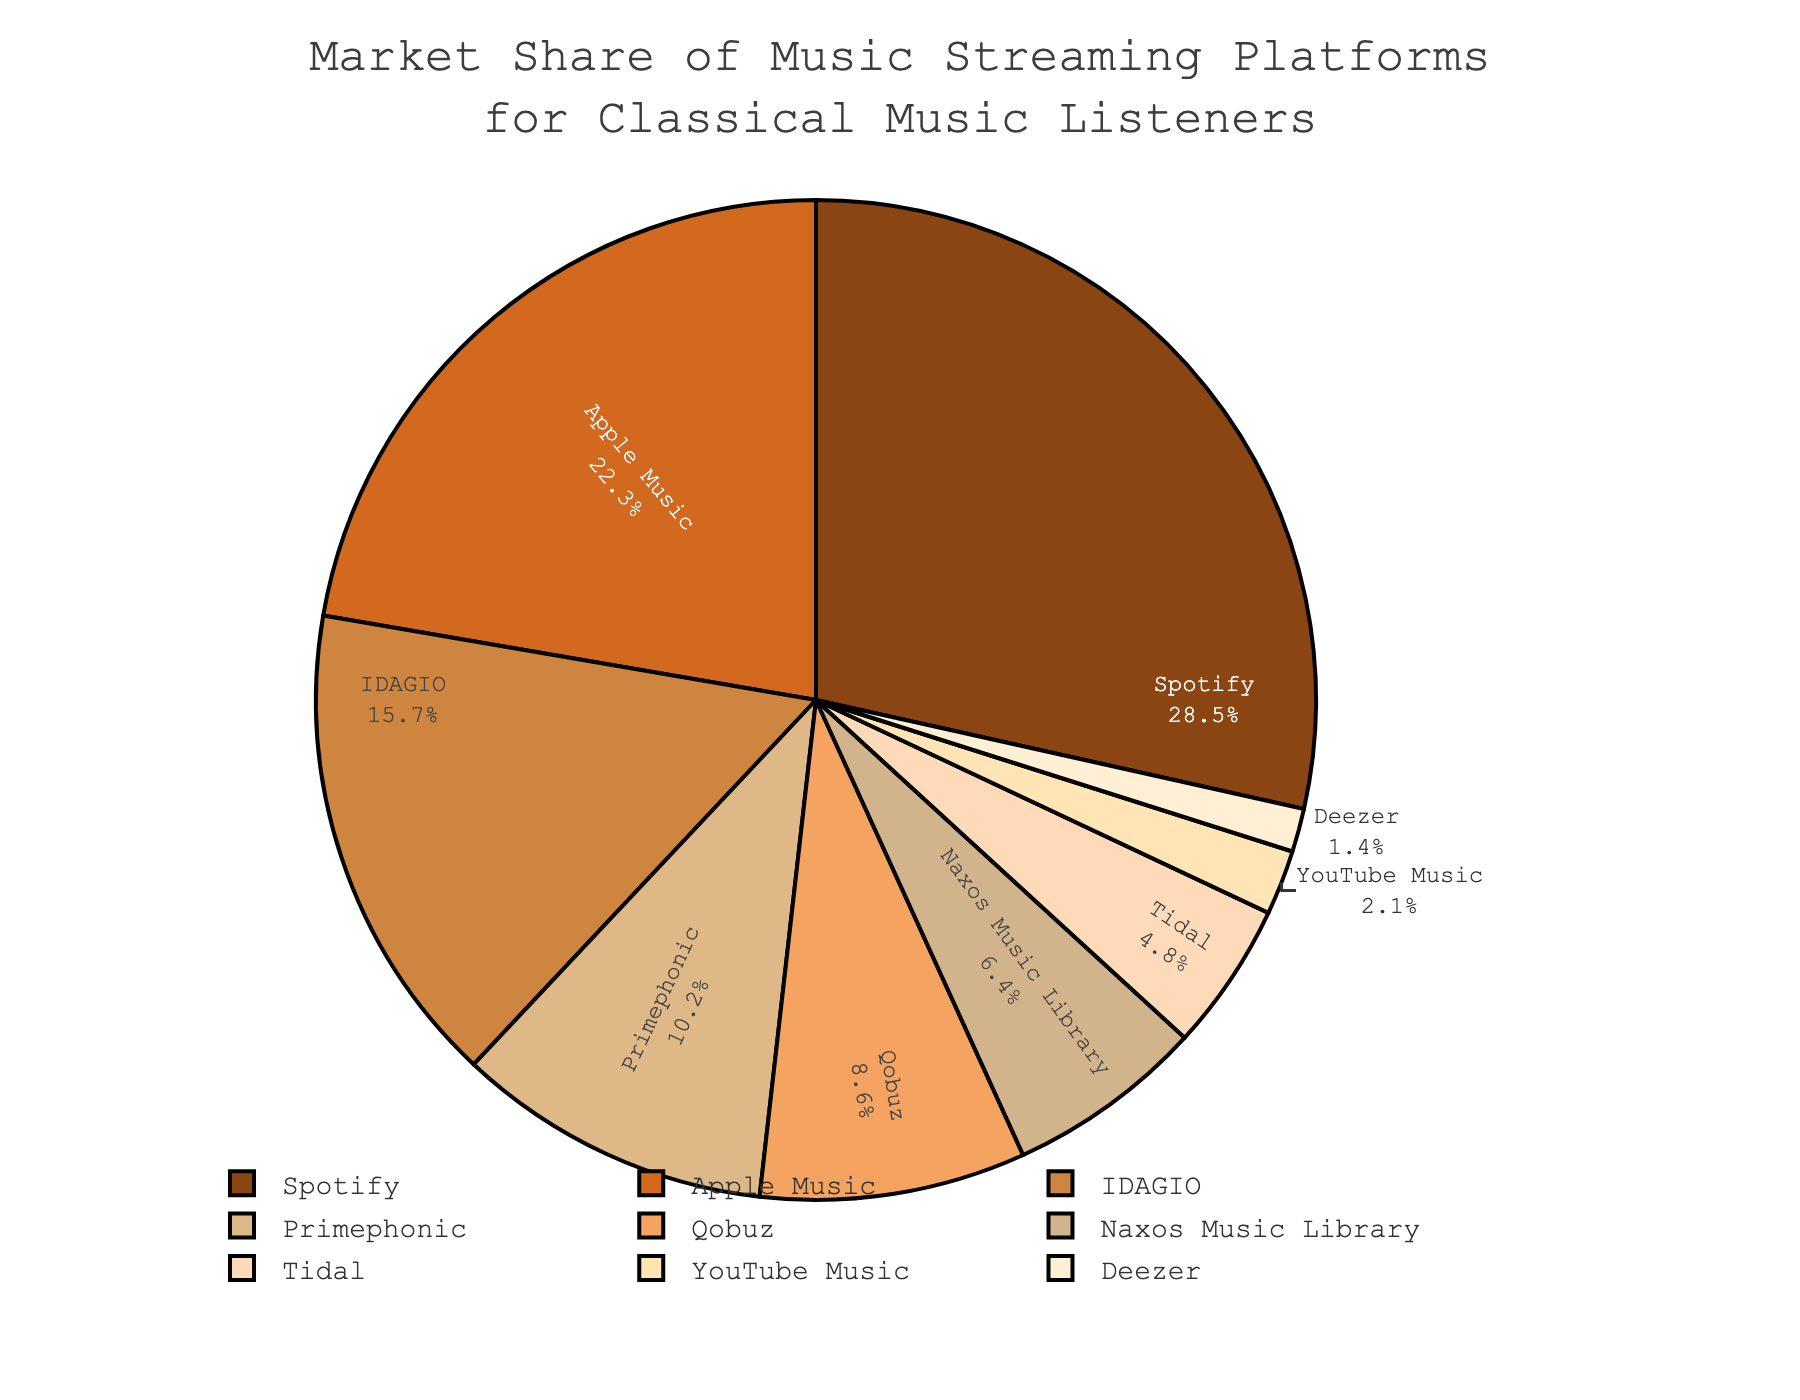Which platform has the highest market share? Look at the labels and corresponding percentages on the pie chart. The platform with the largest percentage is the one with the highest market share.
Answer: Spotify Which platform captures a market share less than 5%? Check the slices of the pie and their respective labels and percentages. Identify the platforms with percentages under 5%.
Answer: Tidal, YouTube Music, Deezer Are there more platforms with a market share above or below 10%? Count the number of platforms with a market share above 10% and compare it with those below 10%. Above 10%: Spotify, Apple Music, IDAGIO, Primephonic (4). Below 10%: Qobuz, Naxos Music Library, Tidal, YouTube Music, Deezer (5).
Answer: Below 10% How much more market share does Spotify have compared to Tidal? Find the market share values for Spotify and Tidal and subtract the smaller value from the larger one (28.5 - 4.8).
Answer: 23.7% Which platforms have a combined market share of 31.1%? Identify and add the market shares of platforms until the sum is approximately 31.1%. IDAGIO (15.7%) + Primephonic (10.2%) + Deezer (1.4%) + YouTube Music (2.1%) is 15.7% + 10.2% + 2.1% + 1.4% = 29.4%.
Answer: IDAGIO, Primephonic, YouTube Music, Deezer What proportion of the market share do the top three platforms occupy relative to the total market? Sum the market shares of the top three platforms (Spotify, Apple Music, IDAGIO) and divide by the total (28.5 + 22.3 + 15.7 = 66.5, total is 100), then multiply by 100.
Answer: 66.5% Which platform is represented by the shade closest to beige? Compare the visual beige shades on the chart near the middle slice labels and identify the platform.
Answer: Qobuz What is the market share difference between the platform with the second lowest and the second highest market share? Identify the platforms accordingly, then subtract the second lowest (YouTube Music, 2.1%) from the second highest (Apple Music, 22.3%). (22.3 - 2.1)
Answer: 20.2% If you exclude Spotify and Apple Music, what is the total market share for the remaining platforms? Sum the market shares of all platforms except Spotify and Apple Music (15.7 + 10.2 + 8.6 + 6.4 + 4.8 + 2.1 + 1.4).
Answer: 49.2% 